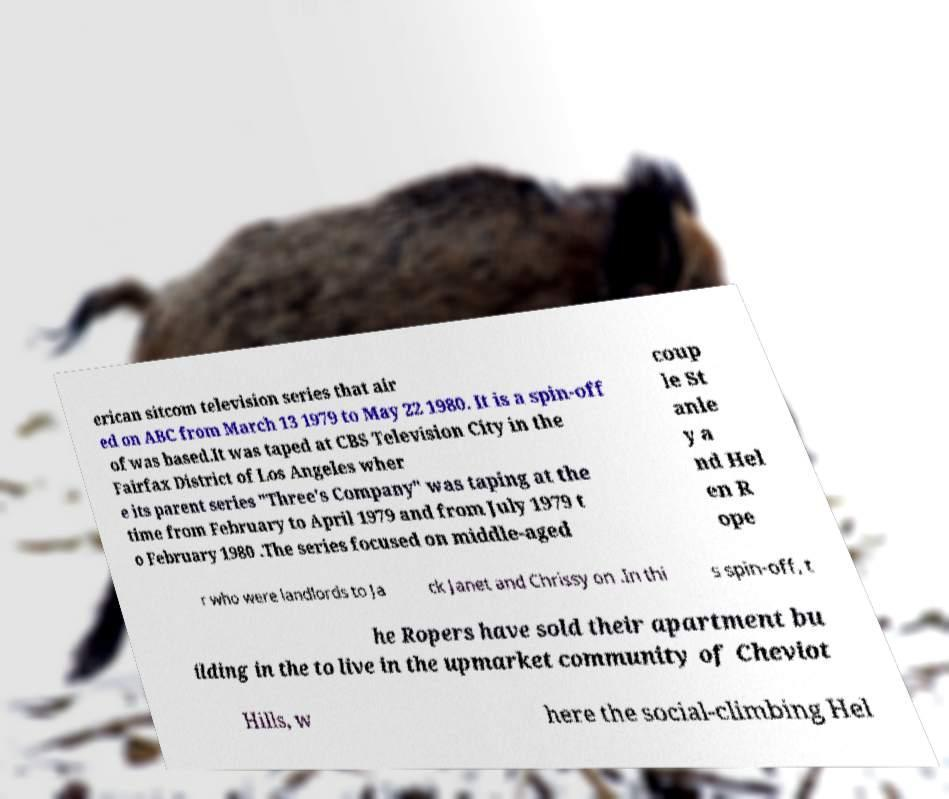Please read and relay the text visible in this image. What does it say? erican sitcom television series that air ed on ABC from March 13 1979 to May 22 1980. It is a spin-off of was based.It was taped at CBS Television City in the Fairfax District of Los Angeles wher e its parent series "Three's Company" was taping at the time from February to April 1979 and from July 1979 t o February 1980 .The series focused on middle-aged coup le St anle y a nd Hel en R ope r who were landlords to Ja ck Janet and Chrissy on .In thi s spin-off, t he Ropers have sold their apartment bu ilding in the to live in the upmarket community of Cheviot Hills, w here the social-climbing Hel 